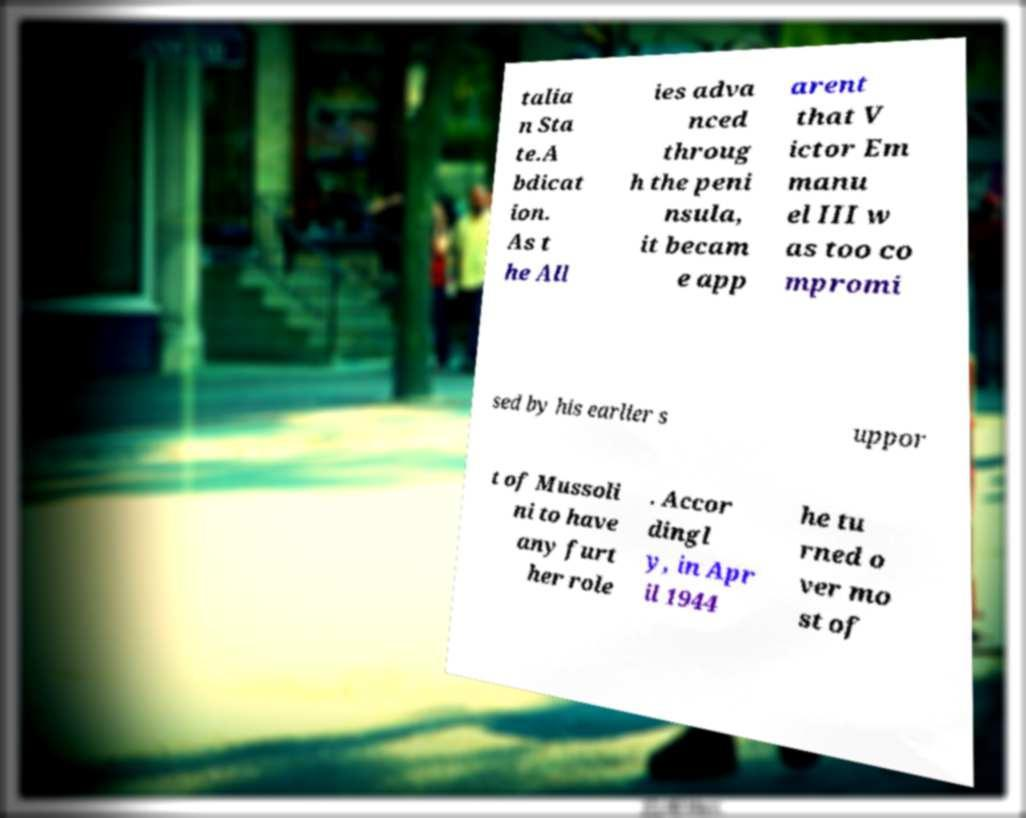Can you read and provide the text displayed in the image?This photo seems to have some interesting text. Can you extract and type it out for me? talia n Sta te.A bdicat ion. As t he All ies adva nced throug h the peni nsula, it becam e app arent that V ictor Em manu el III w as too co mpromi sed by his earlier s uppor t of Mussoli ni to have any furt her role . Accor dingl y, in Apr il 1944 he tu rned o ver mo st of 